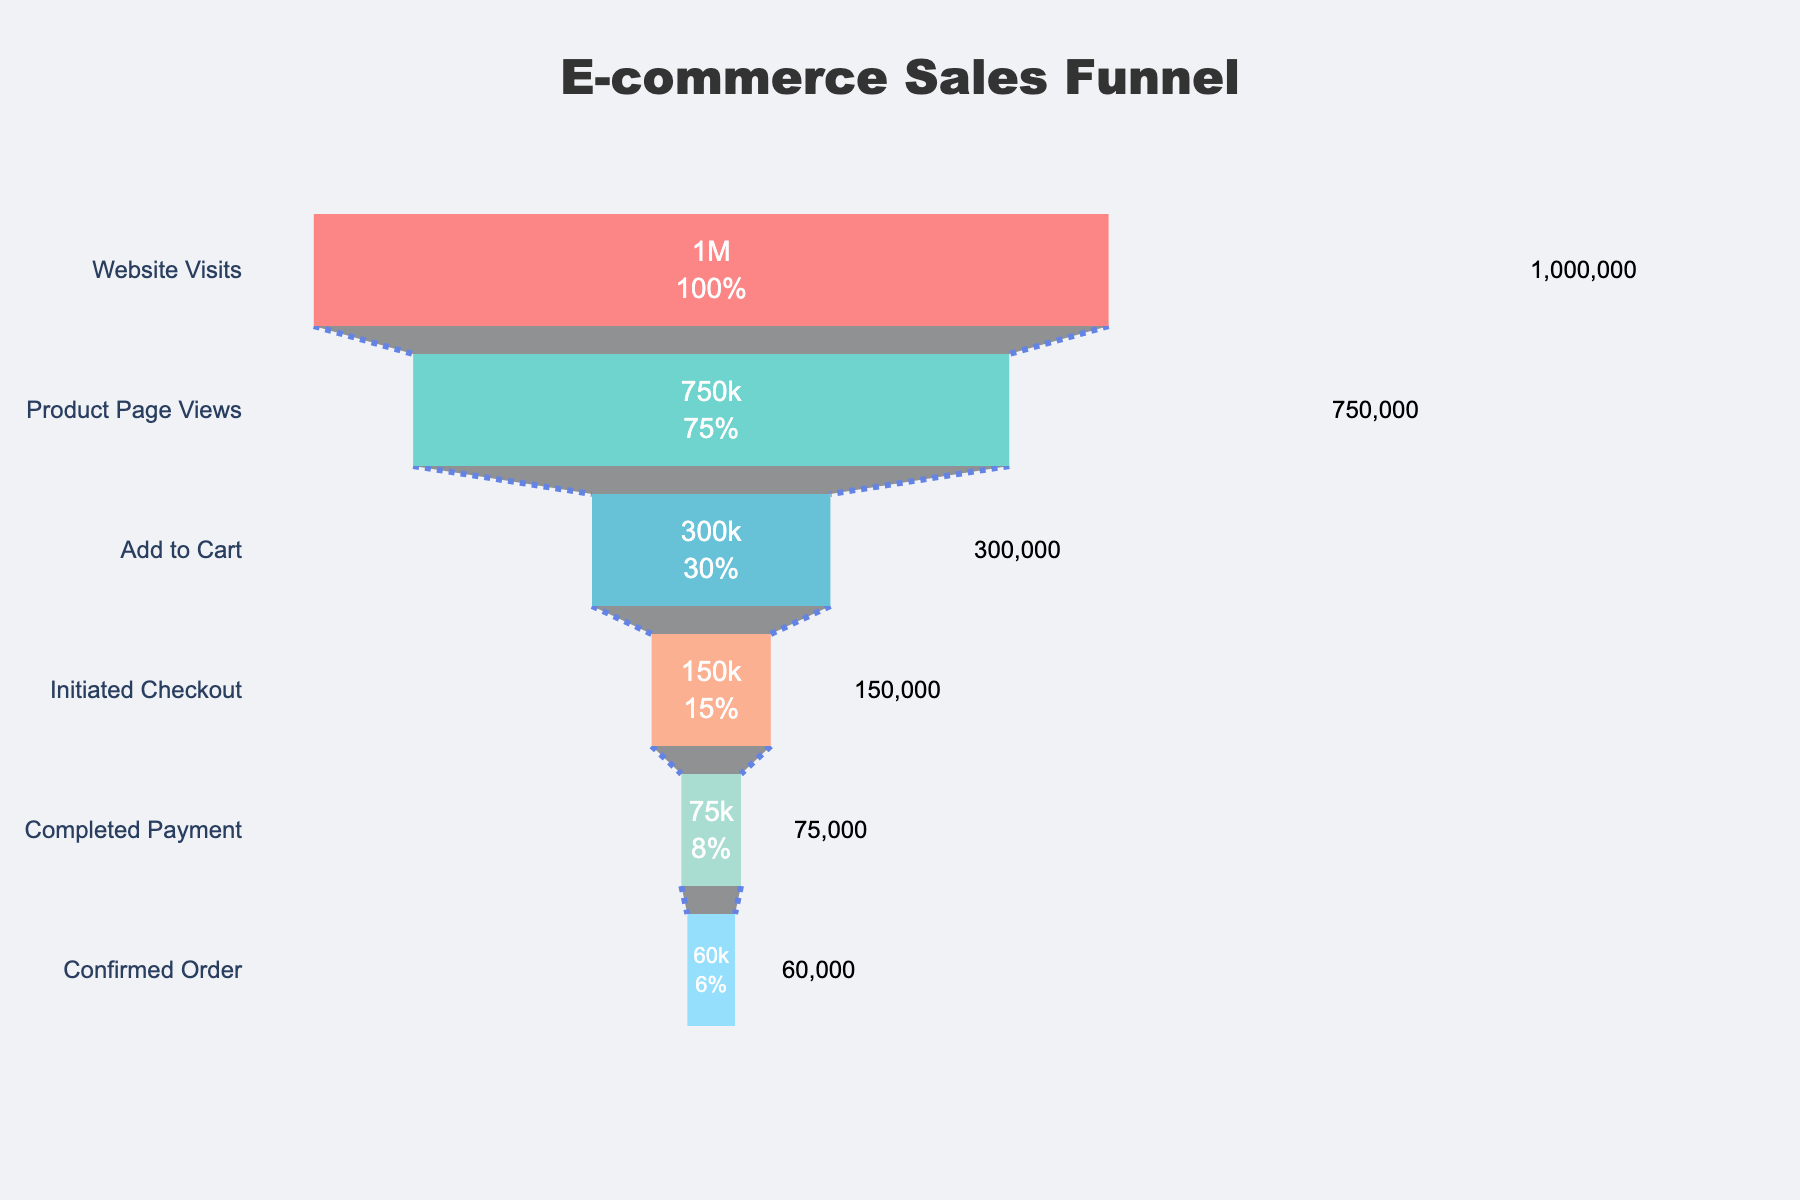What's the title of the funnel chart? The title of the chart is usually displayed prominently at the top. In this case, it reads "E-commerce Sales Funnel"
Answer: E-commerce Sales Funnel What is the stage with the highest number of visitors? The stage with the highest number of visitors is the first stage, which typically represents the initial step in the funnel. Here, it's "Website Visits"
Answer: Website Visits How many visitors initiated checkout? To determine the number of visitors who initiated checkout, we can directly refer to the "Initiated Checkout" stage, which lists the visitor count as 150,000
Answer: 150,000 What is the percentage of visitors who added to cart out of those who viewed the product page? This percentage is calculated by dividing the number of visitors who added to cart by the number of visitors who viewed the product page, then multiplying by 100: (300,000 / 750,000) * 100 = 40%
Answer: 40% By how much do the number of visitors drop from the "Initiated Checkout" stage to the "Completed Payment" stage? The difference can be found by subtracting the number of visitors at the "Completed Payment" stage from the "Initiated Checkout" stage: 150,000 - 75,000 = 75,000
Answer: 75,000 What is the total number of visitors who complete the funnel? The total number of visitors who complete the funnel is represented by the final stage, "Confirmed Order," which has 60,000 visitors
Answer: 60,000 Which stage loses the most visitors compared to the previous stage? To find the stage with the most significant drop, calculate the difference in visitor numbers between consecutive stages and identify the largest one. The most considerable drop occurs between "Product Page Views" and "Add to Cart": 750,000 - 300,000 = 450,000
Answer: Product Page Views to Add to Cart What proportion of initial website visitors completes the payment stage? The proportion is calculated by dividing the number of visitors who complete payment by the total number of initial visitors and multiplying by 100: (75,000 / 1,000,000) * 100 = 7.5%
Answer: 7.5% How many stages are there in the funnel chart? By counting the unique stages along the y-axis, we see there are six stages. They are: "Website Visits", "Product Page Views", "Add to Cart", "Initiated Checkout", "Completed Payment", and "Confirmed Order"
Answer: 6 Which stage has the second highest number of visitors? The second highest number of visitors corresponds to the stage directly below the one with the highest count. Here, after "Website Visits" with 1,000,000, the next stage is "Product Page Views" with 750,000 visitors
Answer: Product Page Views 